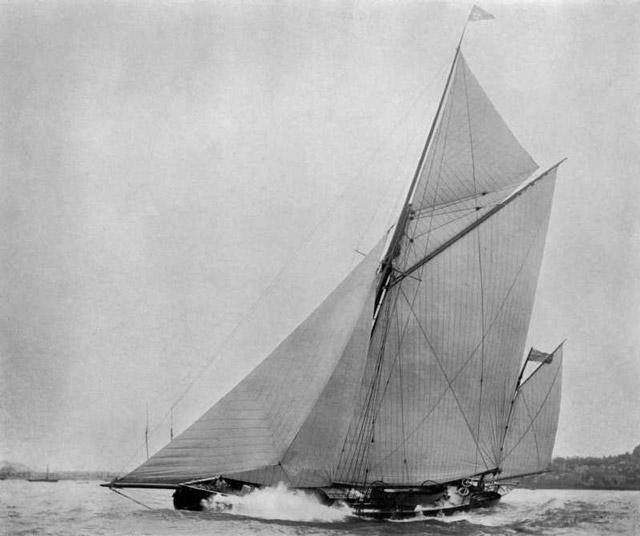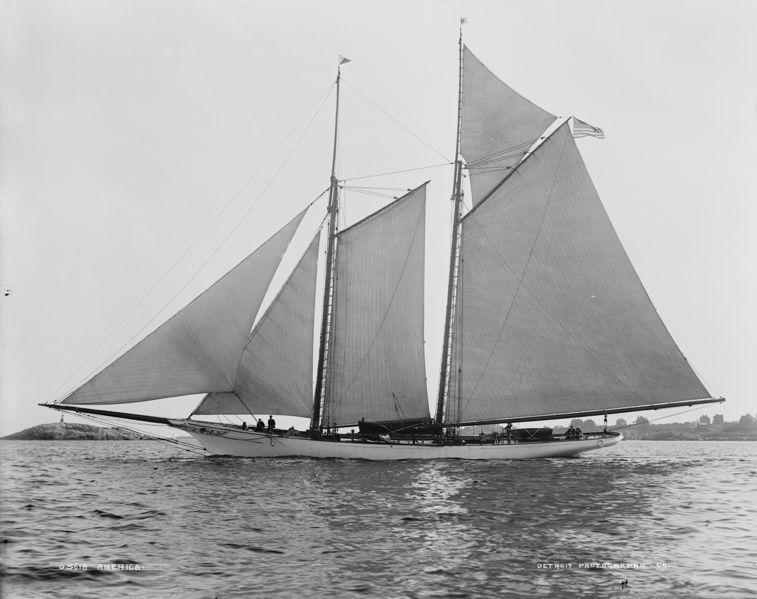The first image is the image on the left, the second image is the image on the right. Given the left and right images, does the statement "An image shows a boat with white sails in a body of blue water." hold true? Answer yes or no. No. The first image is the image on the left, the second image is the image on the right. For the images shown, is this caption "A few clouds are visible in the picture on the left." true? Answer yes or no. No. 